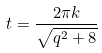Convert formula to latex. <formula><loc_0><loc_0><loc_500><loc_500>t = \frac { 2 \pi k } { \sqrt { q ^ { 2 } + 8 } }</formula> 